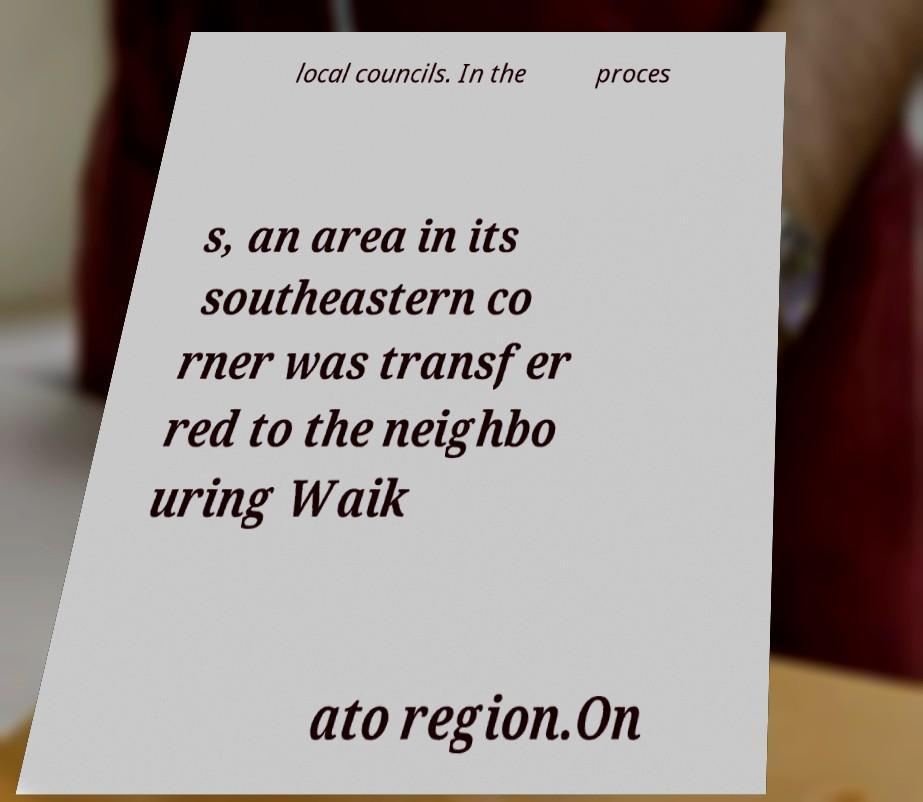Please identify and transcribe the text found in this image. local councils. In the proces s, an area in its southeastern co rner was transfer red to the neighbo uring Waik ato region.On 